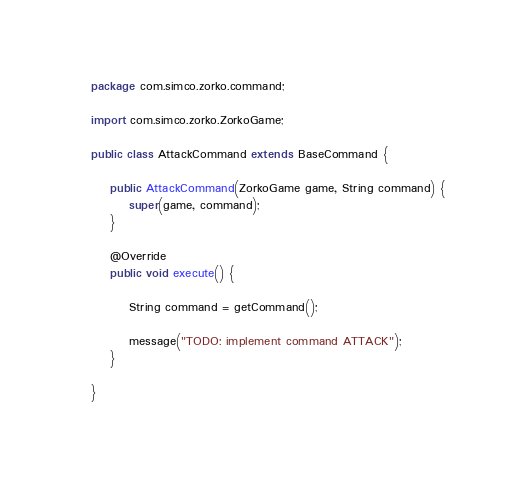<code> <loc_0><loc_0><loc_500><loc_500><_Java_>package com.simco.zorko.command;

import com.simco.zorko.ZorkoGame;

public class AttackCommand extends BaseCommand {

    public AttackCommand(ZorkoGame game, String command) {
        super(game, command);
    }

    @Override
    public void execute() {

        String command = getCommand();

        message("TODO: implement command ATTACK");
    }

}
</code> 